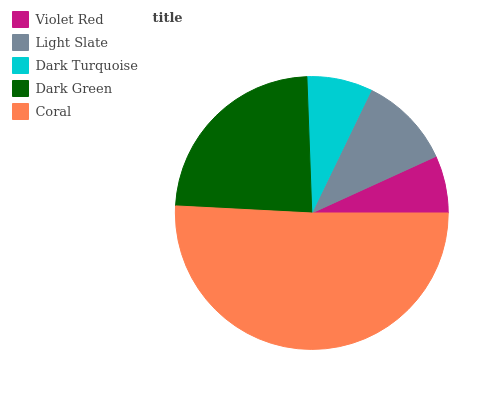Is Violet Red the minimum?
Answer yes or no. Yes. Is Coral the maximum?
Answer yes or no. Yes. Is Light Slate the minimum?
Answer yes or no. No. Is Light Slate the maximum?
Answer yes or no. No. Is Light Slate greater than Violet Red?
Answer yes or no. Yes. Is Violet Red less than Light Slate?
Answer yes or no. Yes. Is Violet Red greater than Light Slate?
Answer yes or no. No. Is Light Slate less than Violet Red?
Answer yes or no. No. Is Light Slate the high median?
Answer yes or no. Yes. Is Light Slate the low median?
Answer yes or no. Yes. Is Violet Red the high median?
Answer yes or no. No. Is Dark Turquoise the low median?
Answer yes or no. No. 